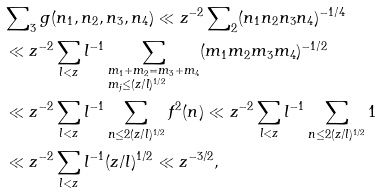Convert formula to latex. <formula><loc_0><loc_0><loc_500><loc_500>& \sum \nolimits _ { 3 } g ( n _ { 1 } , n _ { 2 } , n _ { 3 } , n _ { 4 } ) \ll z ^ { - 2 } \sum \nolimits _ { 2 } ( n _ { 1 } n _ { 2 } n _ { 3 } n _ { 4 } ) ^ { - 1 / 4 } \\ & \ll z ^ { - 2 } \sum _ { l < z } l ^ { - 1 } \sum _ { \begin{subarray} { c } m _ { 1 } + m _ { 2 } = m _ { 3 } + m _ { 4 } \\ m _ { j } \leq ( z / l ) ^ { 1 / 2 } \end{subarray} } ( m _ { 1 } m _ { 2 } m _ { 3 } m _ { 4 } ) ^ { - 1 / 2 } \\ & \ll z ^ { - 2 } \sum _ { l < z } l ^ { - 1 } \sum _ { n \leq 2 ( z / l ) ^ { 1 / 2 } } f ^ { 2 } ( n ) \ll z ^ { - 2 } \sum _ { l < z } l ^ { - 1 } \sum _ { n \leq 2 ( z / l ) ^ { 1 / 2 } } 1 \\ & \ll z ^ { - 2 } \sum _ { l < z } l ^ { - 1 } ( z / l ) ^ { 1 / 2 } \ll z ^ { - 3 / 2 } ,</formula> 